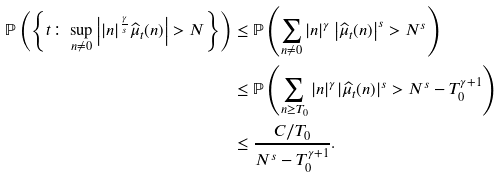<formula> <loc_0><loc_0><loc_500><loc_500>\mathbb { P } \left ( \left \{ t \colon \sup _ { n \ne 0 } \left | | n | ^ { \frac { \gamma } { s } } \widehat { \mu } _ { t } ( n ) \right | > N \right \} \right ) & \leq \mathbb { P } \left ( \sum _ { n \ne 0 } | n | ^ { \gamma } \left | \widehat { \mu } _ { t } ( n ) \right | ^ { s } > N ^ { s } \right ) \\ & \leq \mathbb { P } \left ( \sum _ { n \geq T _ { 0 } } | n | ^ { \gamma } | \widehat { \mu } _ { t } ( n ) | ^ { s } > N ^ { s } - T _ { 0 } ^ { \gamma + 1 } \right ) \\ & \leq \frac { C / T _ { 0 } } { N ^ { s } - T _ { 0 } ^ { \gamma + 1 } } .</formula> 